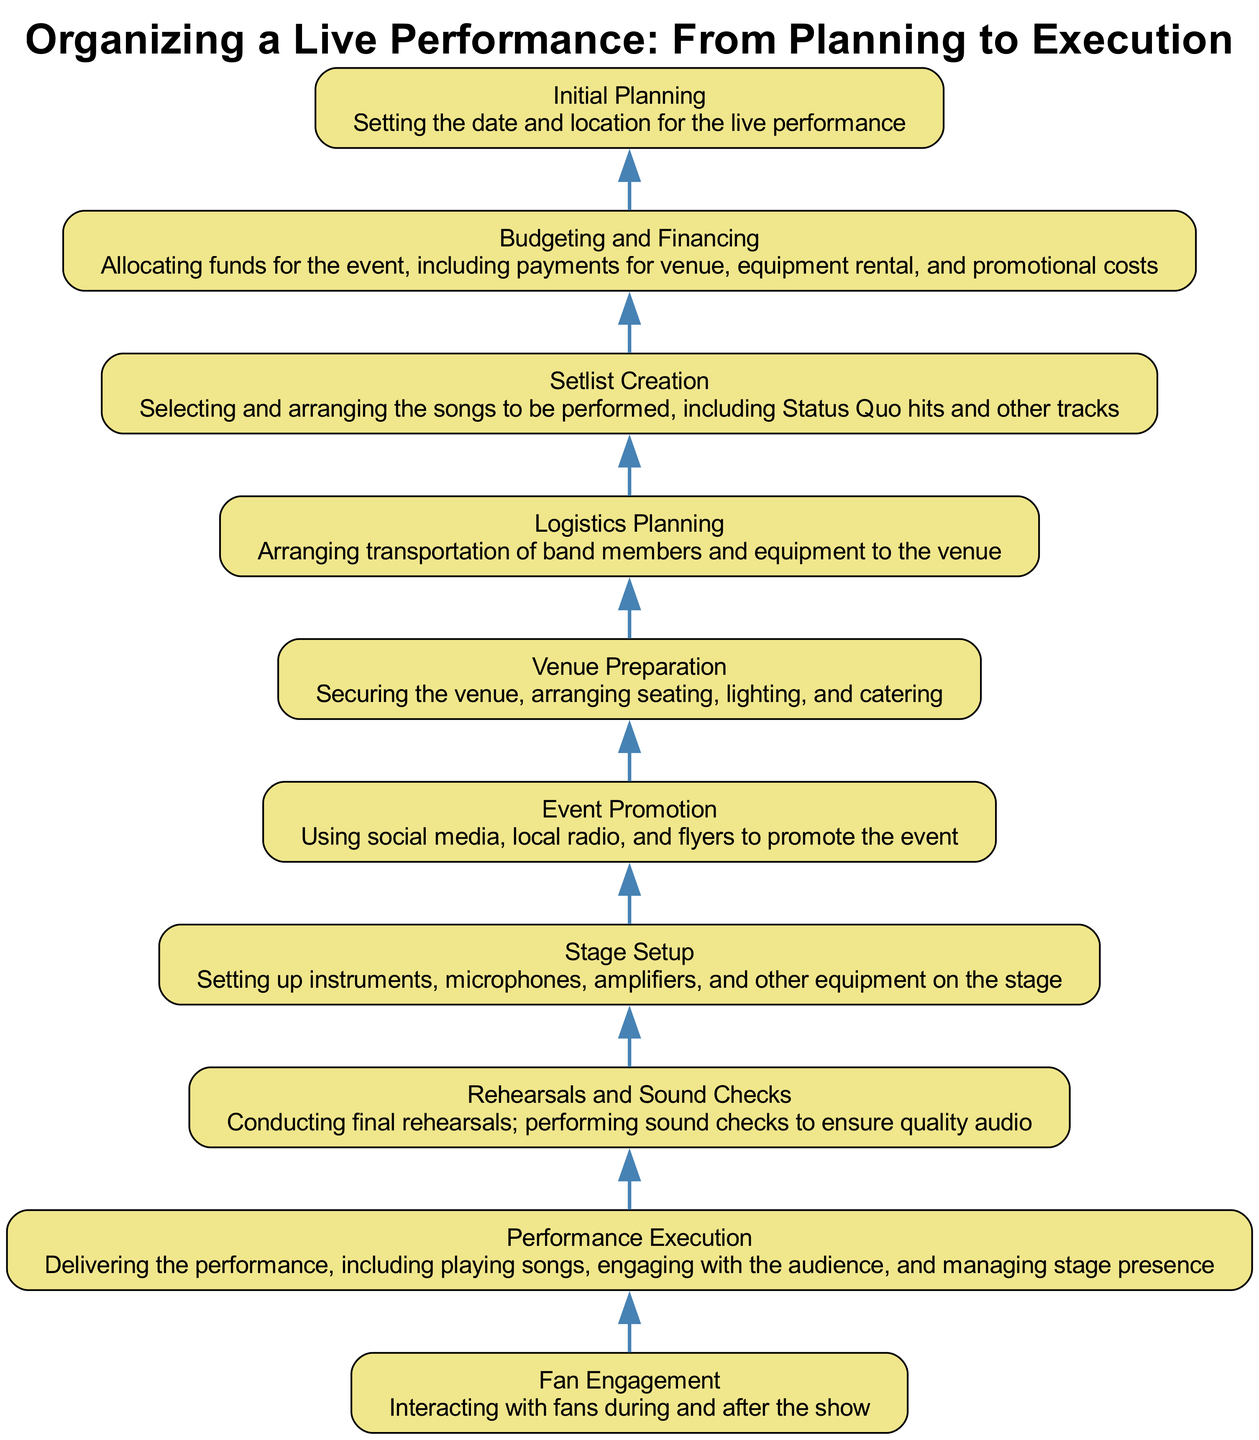What is the first step in organizing a live performance? The diagram shows that the first step is "Initial Planning," which involves setting the date and location for the live performance.
Answer: Initial Planning How many nodes are in the diagram? The diagram consists of ten different nodes, each representing a step in organizing a live performance.
Answer: 10 What is the last step before "Performance Execution"? According to the flow, "Rehearsals and Sound Checks" is the step that precedes "Performance Execution."
Answer: Rehearsals and Sound Checks Which step comes directly before "Stage Setup"? The diagram indicates that "Venue Preparation" comes directly before "Stage Setup."
Answer: Venue Preparation What is one method used for "Event Promotion"? The diagram lists one method as using social media to promote the event.
Answer: Social media What is the relationship between "Budgeting and Financing" and "Logistics Planning"? "Budgeting and Financing" comes before "Logistics Planning," indicating that financial planning happens before arranging logistics.
Answer: Budgeting and Financing → Logistics Planning Which steps focus on audience interaction? The steps "Fan Engagement" and "Performance Execution" both emphasize engaging and interacting with the audience during the event.
Answer: Fan Engagement, Performance Execution How does the flow of the diagram depict the process of organizing a live performance? The flow chart is structured from bottom to top, illustrating a sequential process that starts with planning and ends with fan engagement. Each step connects logically to the next to create a complete workflow.
Answer: Sequential process from planning to engagement What is the primary purpose of "Setlist Creation"? The purpose of "Setlist Creation" is to select and arrange the songs to be performed during the live show.
Answer: Select and arrange songs 